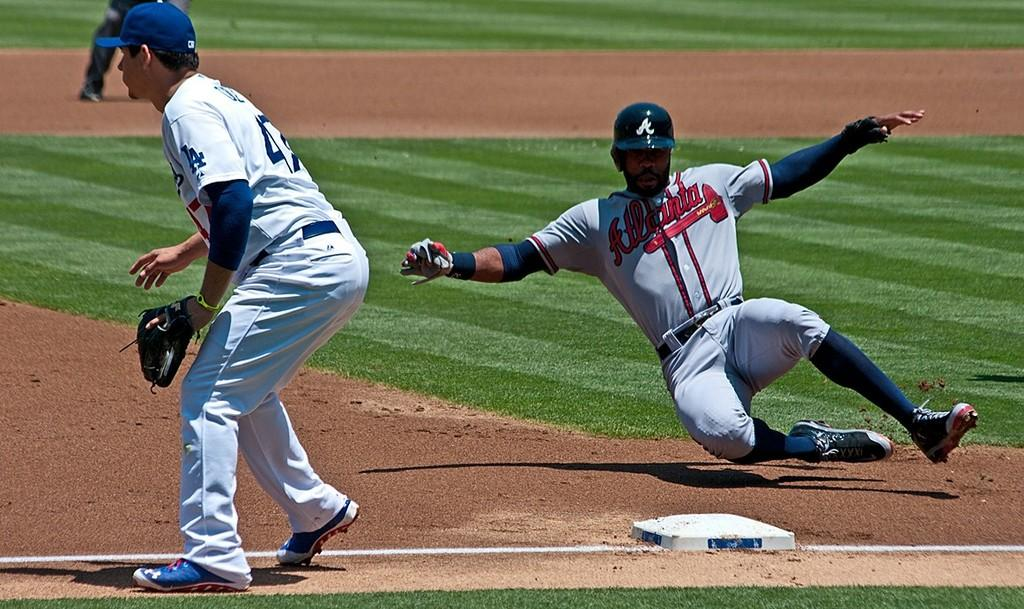How many people are in the image? There are two persons in the image. What is happening to one of the persons? One of the persons is falling down. What activity are they engaged in? They are playing baseball. Can you describe any other visible body parts in the image? There are legs of a person visible in the background. What type of bubble is floating near the baseball players in the image? There is no bubble present in the image; it features two persons playing baseball. 